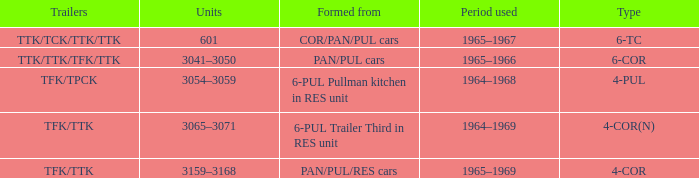Name the trailers for formed from pan/pul/res cars TFK/TTK. 